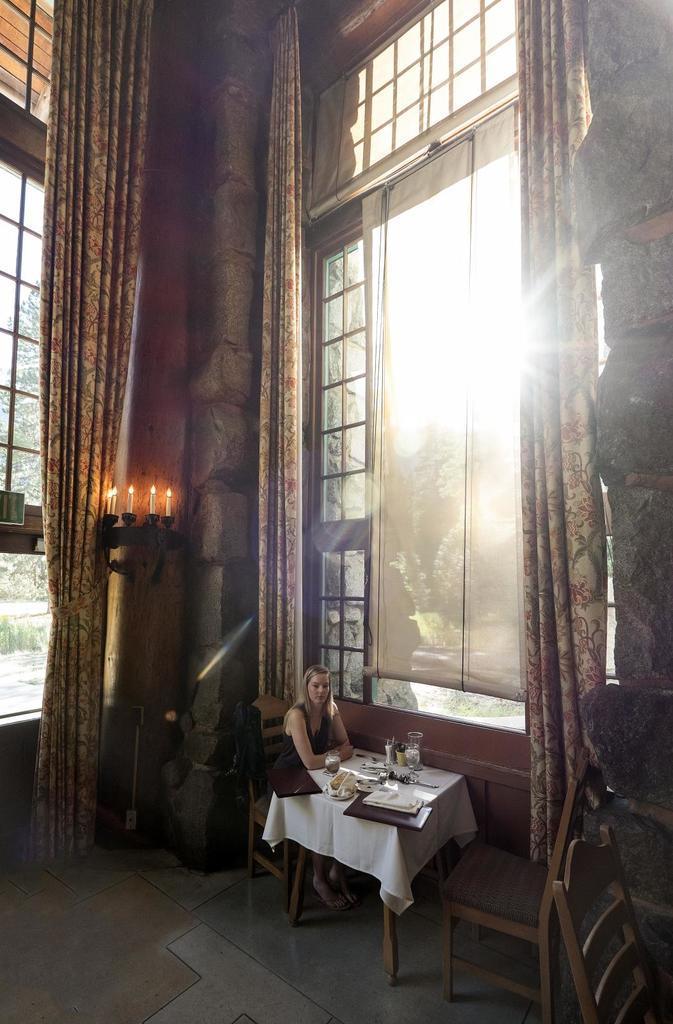Could you give a brief overview of what you see in this image? In this image we can see a lady sitting and there is a table. We can see glasses and some objects placed on the table. There are chairs and we can see candles placed on the holder. There are curtains and we can see windows. 